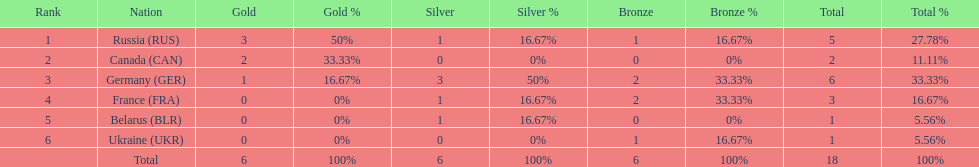Parse the full table. {'header': ['Rank', 'Nation', 'Gold', 'Gold %', 'Silver', 'Silver %', 'Bronze', 'Bronze %', 'Total', 'Total %'], 'rows': [['1', 'Russia\xa0(RUS)', '3', '50%', '1', '16.67%', '1', '16.67%', '5', '27.78%'], ['2', 'Canada\xa0(CAN)', '2', '33.33%', '0', '0%', '0', '0%', '2', '11.11%'], ['3', 'Germany\xa0(GER)', '1', '16.67%', '3', '50%', '2', '33.33%', '6', '33.33%'], ['4', 'France\xa0(FRA)', '0', '0%', '1', '16.67%', '2', '33.33%', '3', '16.67%'], ['5', 'Belarus\xa0(BLR)', '0', '0%', '1', '16.67%', '0', '0%', '1', '5.56%'], ['6', 'Ukraine\xa0(UKR)', '0', '0%', '0', '0%', '1', '16.67%', '1', '5.56%'], ['', 'Total', '6', '100%', '6', '100%', '6', '100%', '18', '100%']]} What was the total number of silver medals awarded to the french and the germans in the 1994 winter olympic biathlon? 4. 